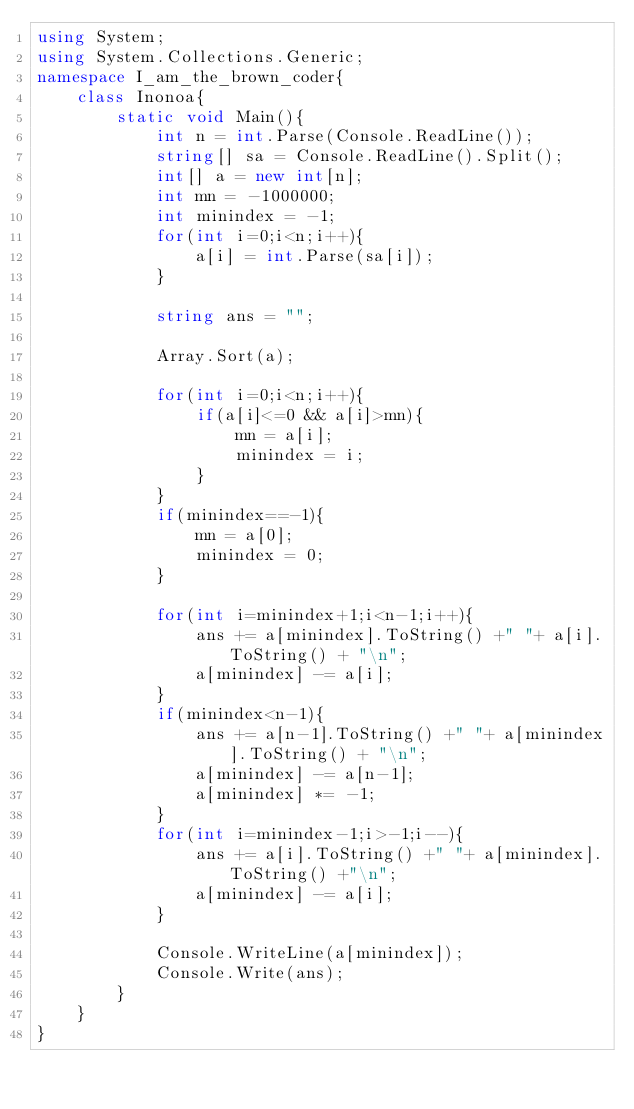Convert code to text. <code><loc_0><loc_0><loc_500><loc_500><_C#_>using System;
using System.Collections.Generic;
namespace I_am_the_brown_coder{
    class Inonoa{
        static void Main(){
            int n = int.Parse(Console.ReadLine());
            string[] sa = Console.ReadLine().Split();
            int[] a = new int[n];
            int mn = -1000000;
            int minindex = -1;
            for(int i=0;i<n;i++){
                a[i] = int.Parse(sa[i]);
            }

            string ans = "";

            Array.Sort(a);

            for(int i=0;i<n;i++){
                if(a[i]<=0 && a[i]>mn){
                    mn = a[i];
                    minindex = i;
                }
            }
            if(minindex==-1){
                mn = a[0];
                minindex = 0;
            }

            for(int i=minindex+1;i<n-1;i++){
                ans += a[minindex].ToString() +" "+ a[i].ToString() + "\n";
                a[minindex] -= a[i];
            }
            if(minindex<n-1){
                ans += a[n-1].ToString() +" "+ a[minindex].ToString() + "\n";
                a[minindex] -= a[n-1];
                a[minindex] *= -1;
            }
            for(int i=minindex-1;i>-1;i--){
                ans += a[i].ToString() +" "+ a[minindex].ToString() +"\n";
                a[minindex] -= a[i];
            }
            
            Console.WriteLine(a[minindex]);
            Console.Write(ans);
        }
    }
}</code> 